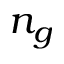<formula> <loc_0><loc_0><loc_500><loc_500>n _ { g }</formula> 